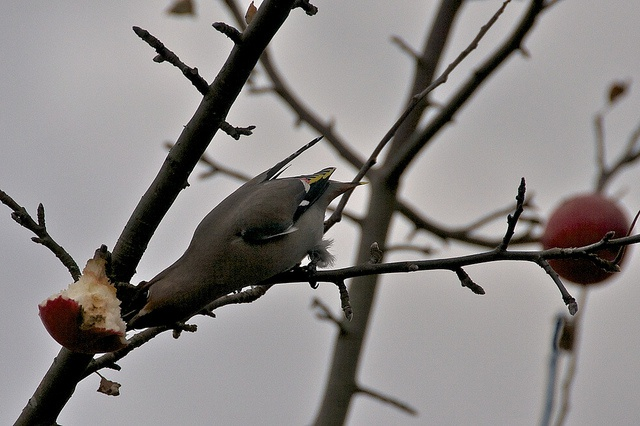Describe the objects in this image and their specific colors. I can see bird in darkgray, black, and gray tones, apple in darkgray, black, maroon, and brown tones, and apple in darkgray, black, gray, and maroon tones in this image. 